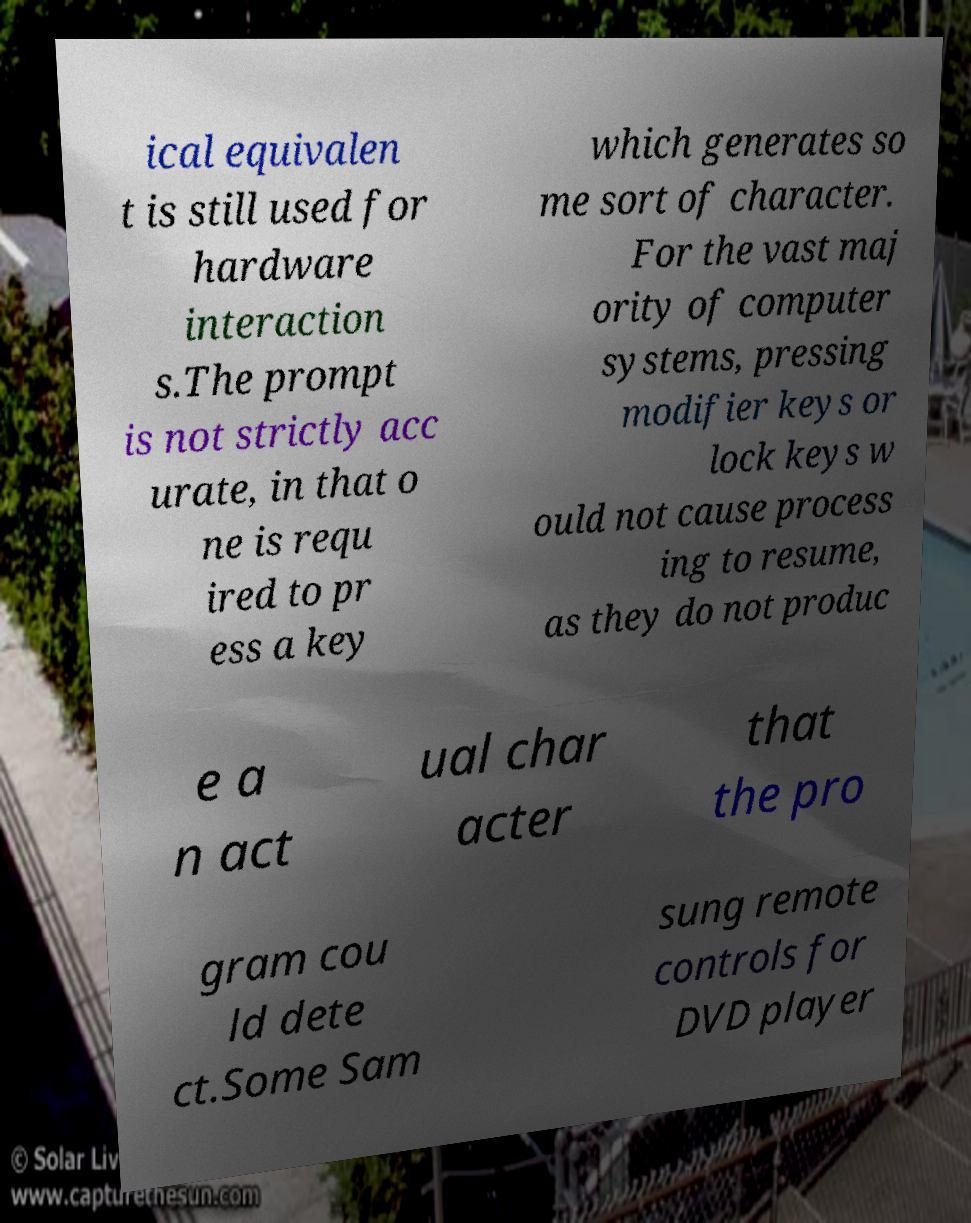Please read and relay the text visible in this image. What does it say? ical equivalen t is still used for hardware interaction s.The prompt is not strictly acc urate, in that o ne is requ ired to pr ess a key which generates so me sort of character. For the vast maj ority of computer systems, pressing modifier keys or lock keys w ould not cause process ing to resume, as they do not produc e a n act ual char acter that the pro gram cou ld dete ct.Some Sam sung remote controls for DVD player 